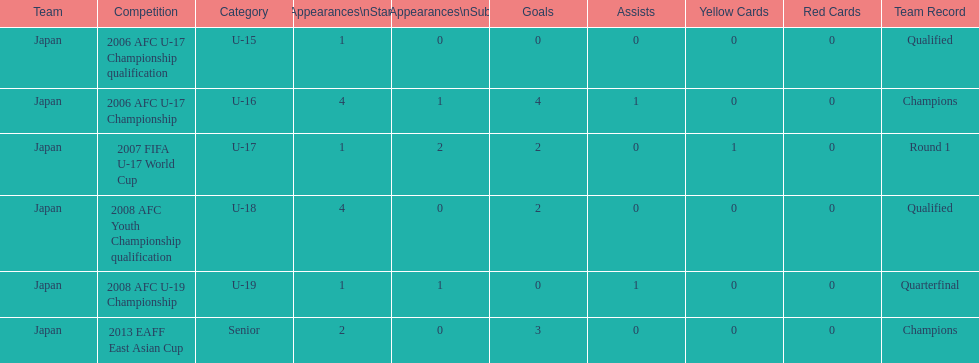How many major events featured yoichiro kakitani scoring at least two goals? 2. 